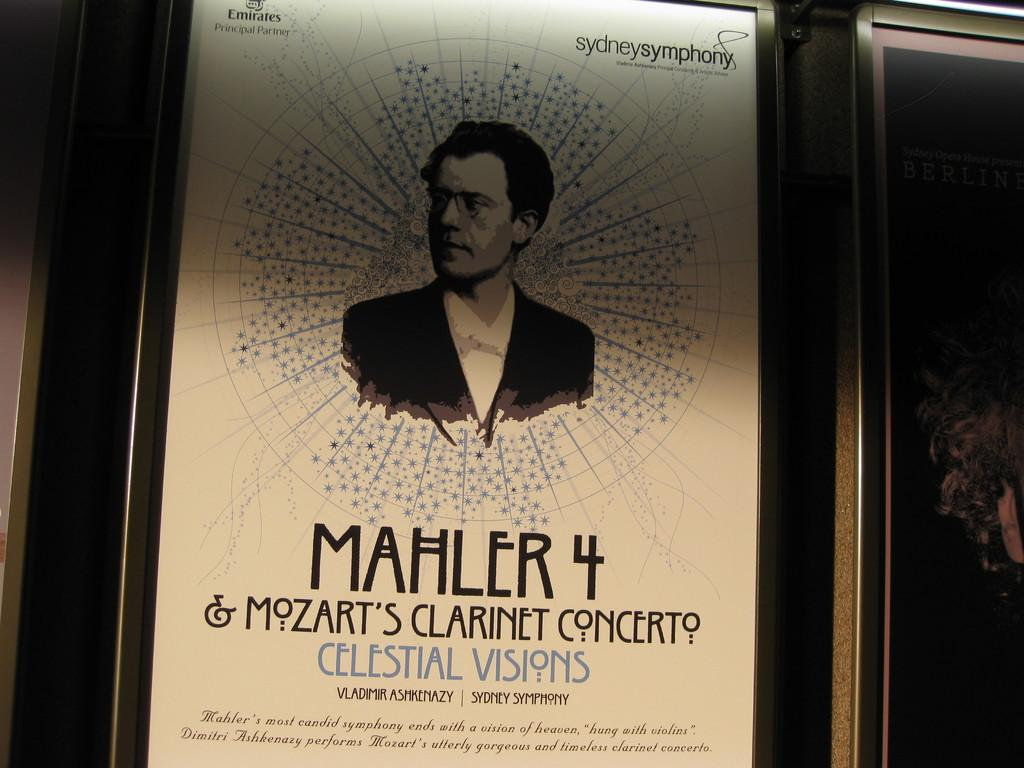<image>
Describe the image concisely. A poster for a concert featuring both Mahler 4 and Mozart's Clarinet concerto. 